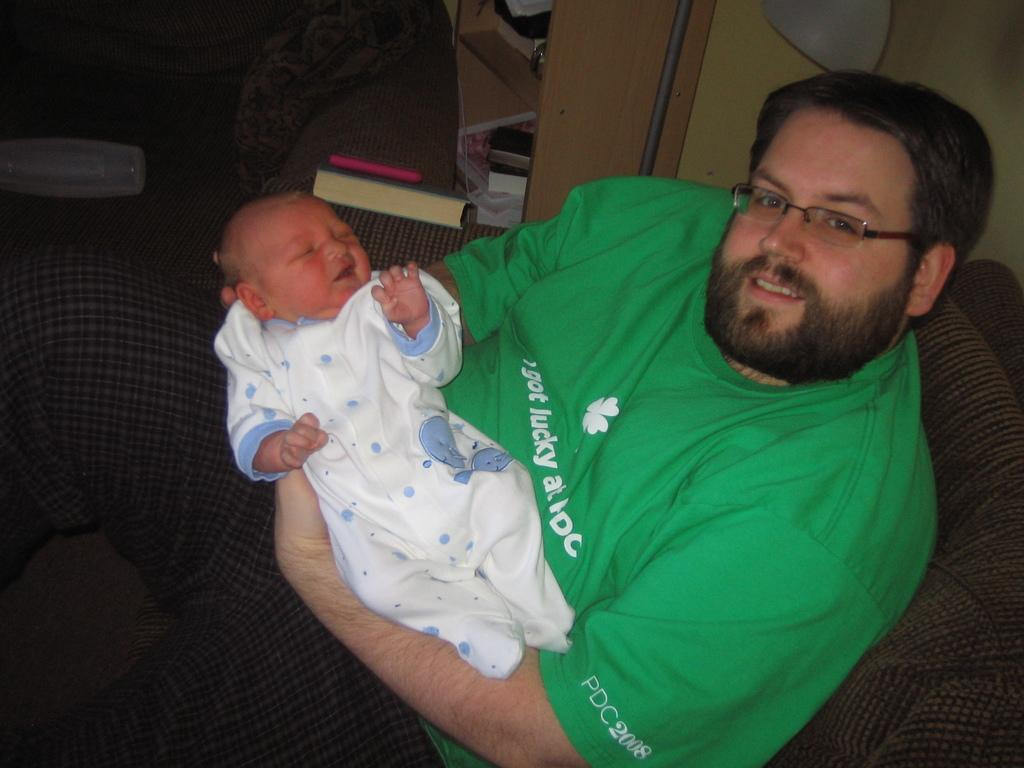<image>
Create a compact narrative representing the image presented. A bearded man holding an infant wearing a green shirt sponsored by DC 2008. 